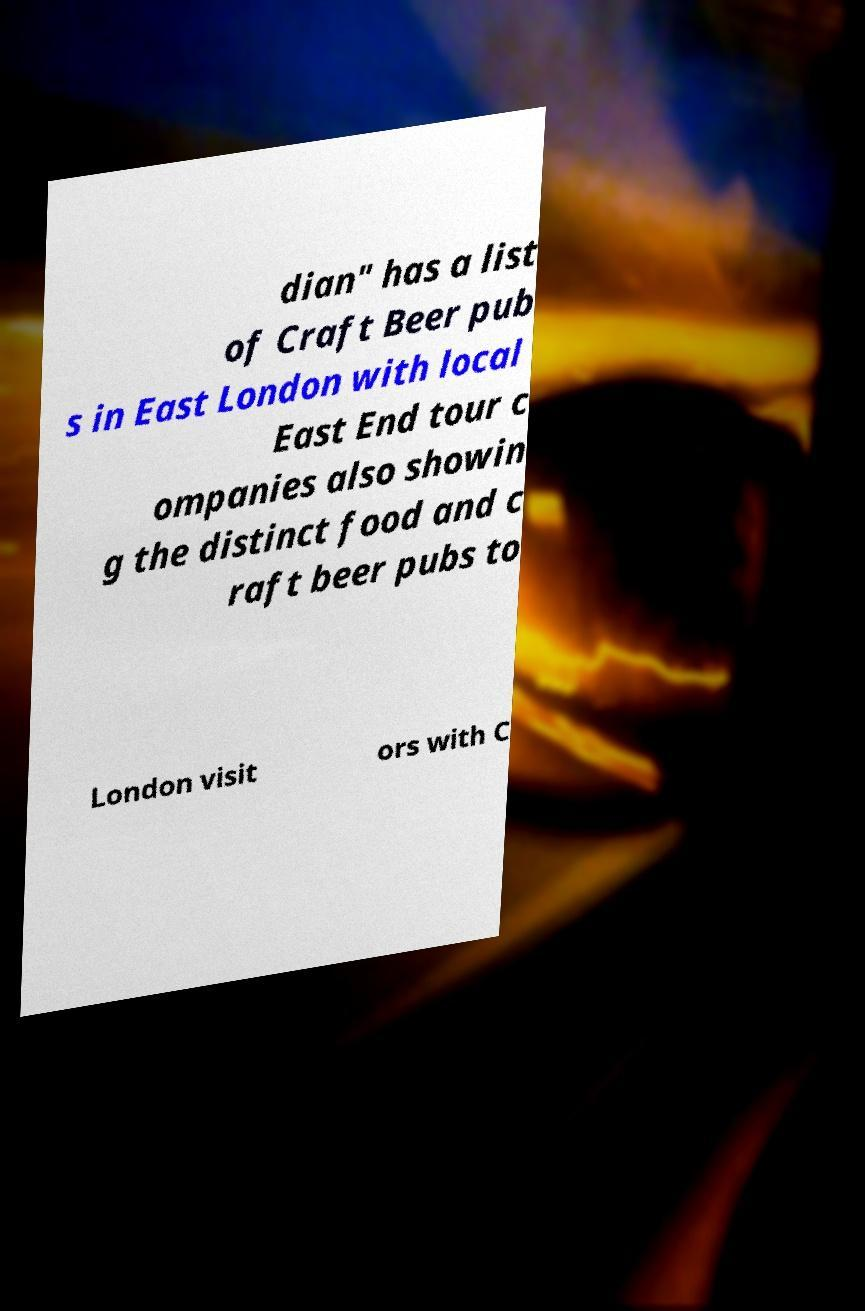Please read and relay the text visible in this image. What does it say? dian" has a list of Craft Beer pub s in East London with local East End tour c ompanies also showin g the distinct food and c raft beer pubs to London visit ors with C 